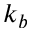Convert formula to latex. <formula><loc_0><loc_0><loc_500><loc_500>k _ { b }</formula> 